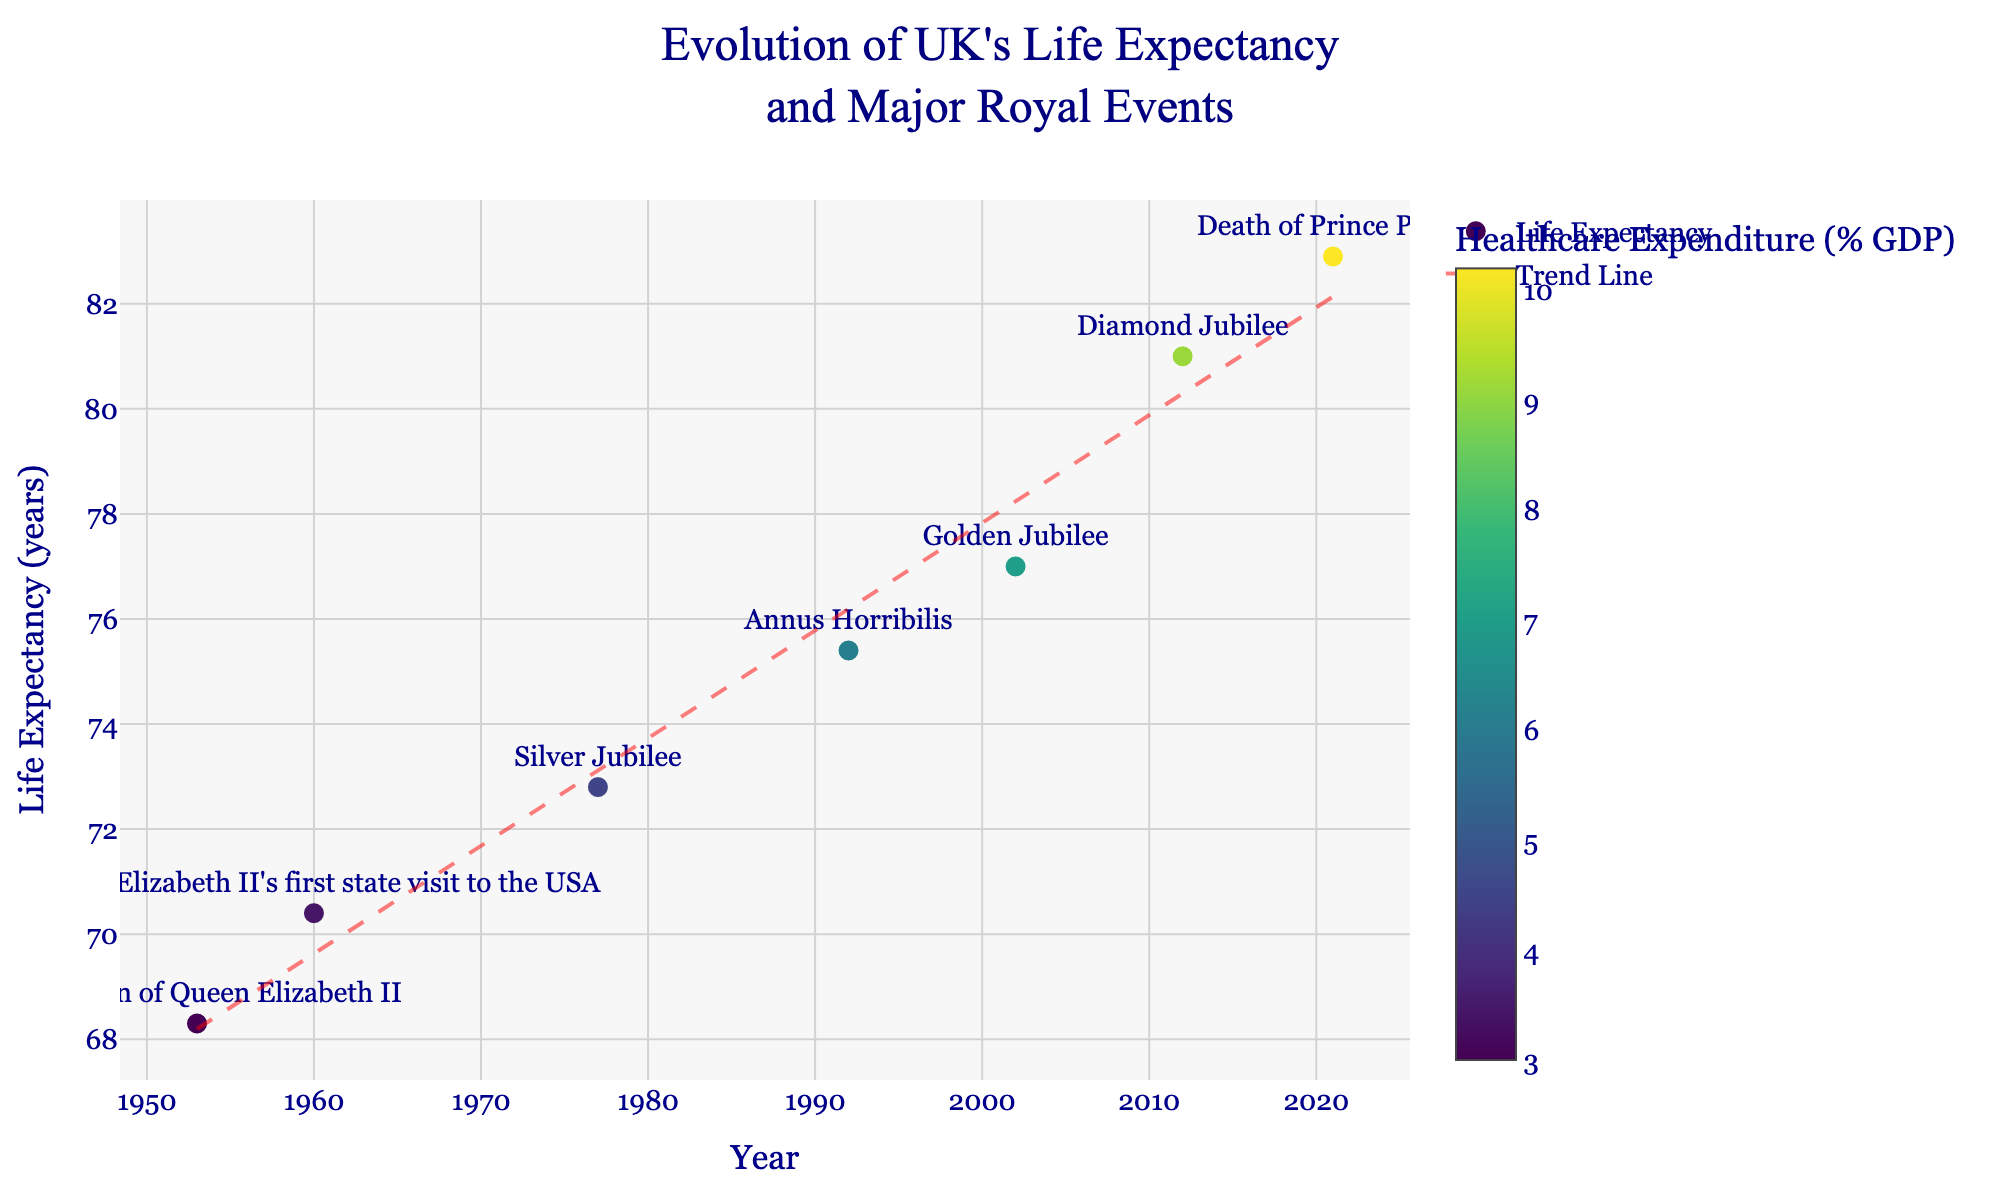How many major royal events are listed in the dataset? Count the number of entries under the "Event" column in the scatter plot. Each event corresponds to a unique data point with its label.
Answer: 7 What is the title of the figure? The title is shown at the top of the figure.
Answer: "Evolution of UK's Life Expectancy and Major Royal Events" What color represents the highest healthcare expenditure (% GDP)? Look at the color gradient scale on the right side of the figure. The highest healthcare expenditure should correspond to the darkest shade on the Viridis color scale.
Answer: Dark green Which event corresponds to the lowest life expectancy recorded? Identify the data point with the lowest y-value (Life Expectancy) on the scatter plot and check its label.
Answer: Coronation of Queen Elizabeth II What is the trend line indicating about life expectancy over time? The trend line, represented by a dashed red line, shows the general direction and slope of life expectancy data points over the years. It indicates whether life expectancy is increasing, decreasing, or remaining constant.
Answer: Increasing Was life expectancy higher in 2002 or 2012? Compare the y-values for the years 2002 and 2012 on the scatter plot.
Answer: 2012 What is the average life expectancy for the years shown in the figure? Sum the life expectancy values for all the years and divide by the number of data points: (68.3 + 70.4 + 72.8 + 75.4 + 77.0 + 81.0 + 82.9) / 7 = 527.8 / 7
Answer: 75.4 Which year shows the highest healthcare expenditure as a percentage of GDP? Identify the data point with the darkest color (corresponding to the highest value on the color scale) and note its year.
Answer: 2021 Is there a strong correlation between healthcare expenditure and life expectancy in the figure? Observe the colors (which represent healthcare expenditure) in relation to their corresponding points' y-values (life expectancy). Analyze if higher expenditures mostly match higher life expectancy values and vice versa.
Answer: Yes 